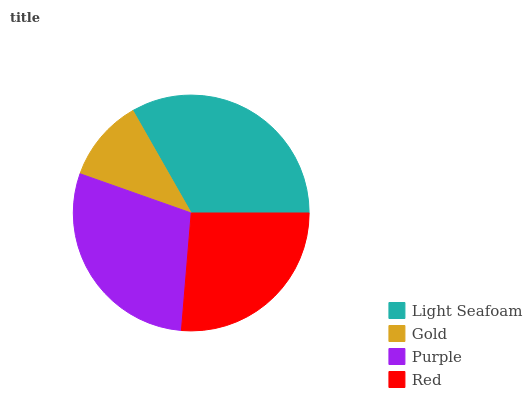Is Gold the minimum?
Answer yes or no. Yes. Is Light Seafoam the maximum?
Answer yes or no. Yes. Is Purple the minimum?
Answer yes or no. No. Is Purple the maximum?
Answer yes or no. No. Is Purple greater than Gold?
Answer yes or no. Yes. Is Gold less than Purple?
Answer yes or no. Yes. Is Gold greater than Purple?
Answer yes or no. No. Is Purple less than Gold?
Answer yes or no. No. Is Purple the high median?
Answer yes or no. Yes. Is Red the low median?
Answer yes or no. Yes. Is Red the high median?
Answer yes or no. No. Is Gold the low median?
Answer yes or no. No. 